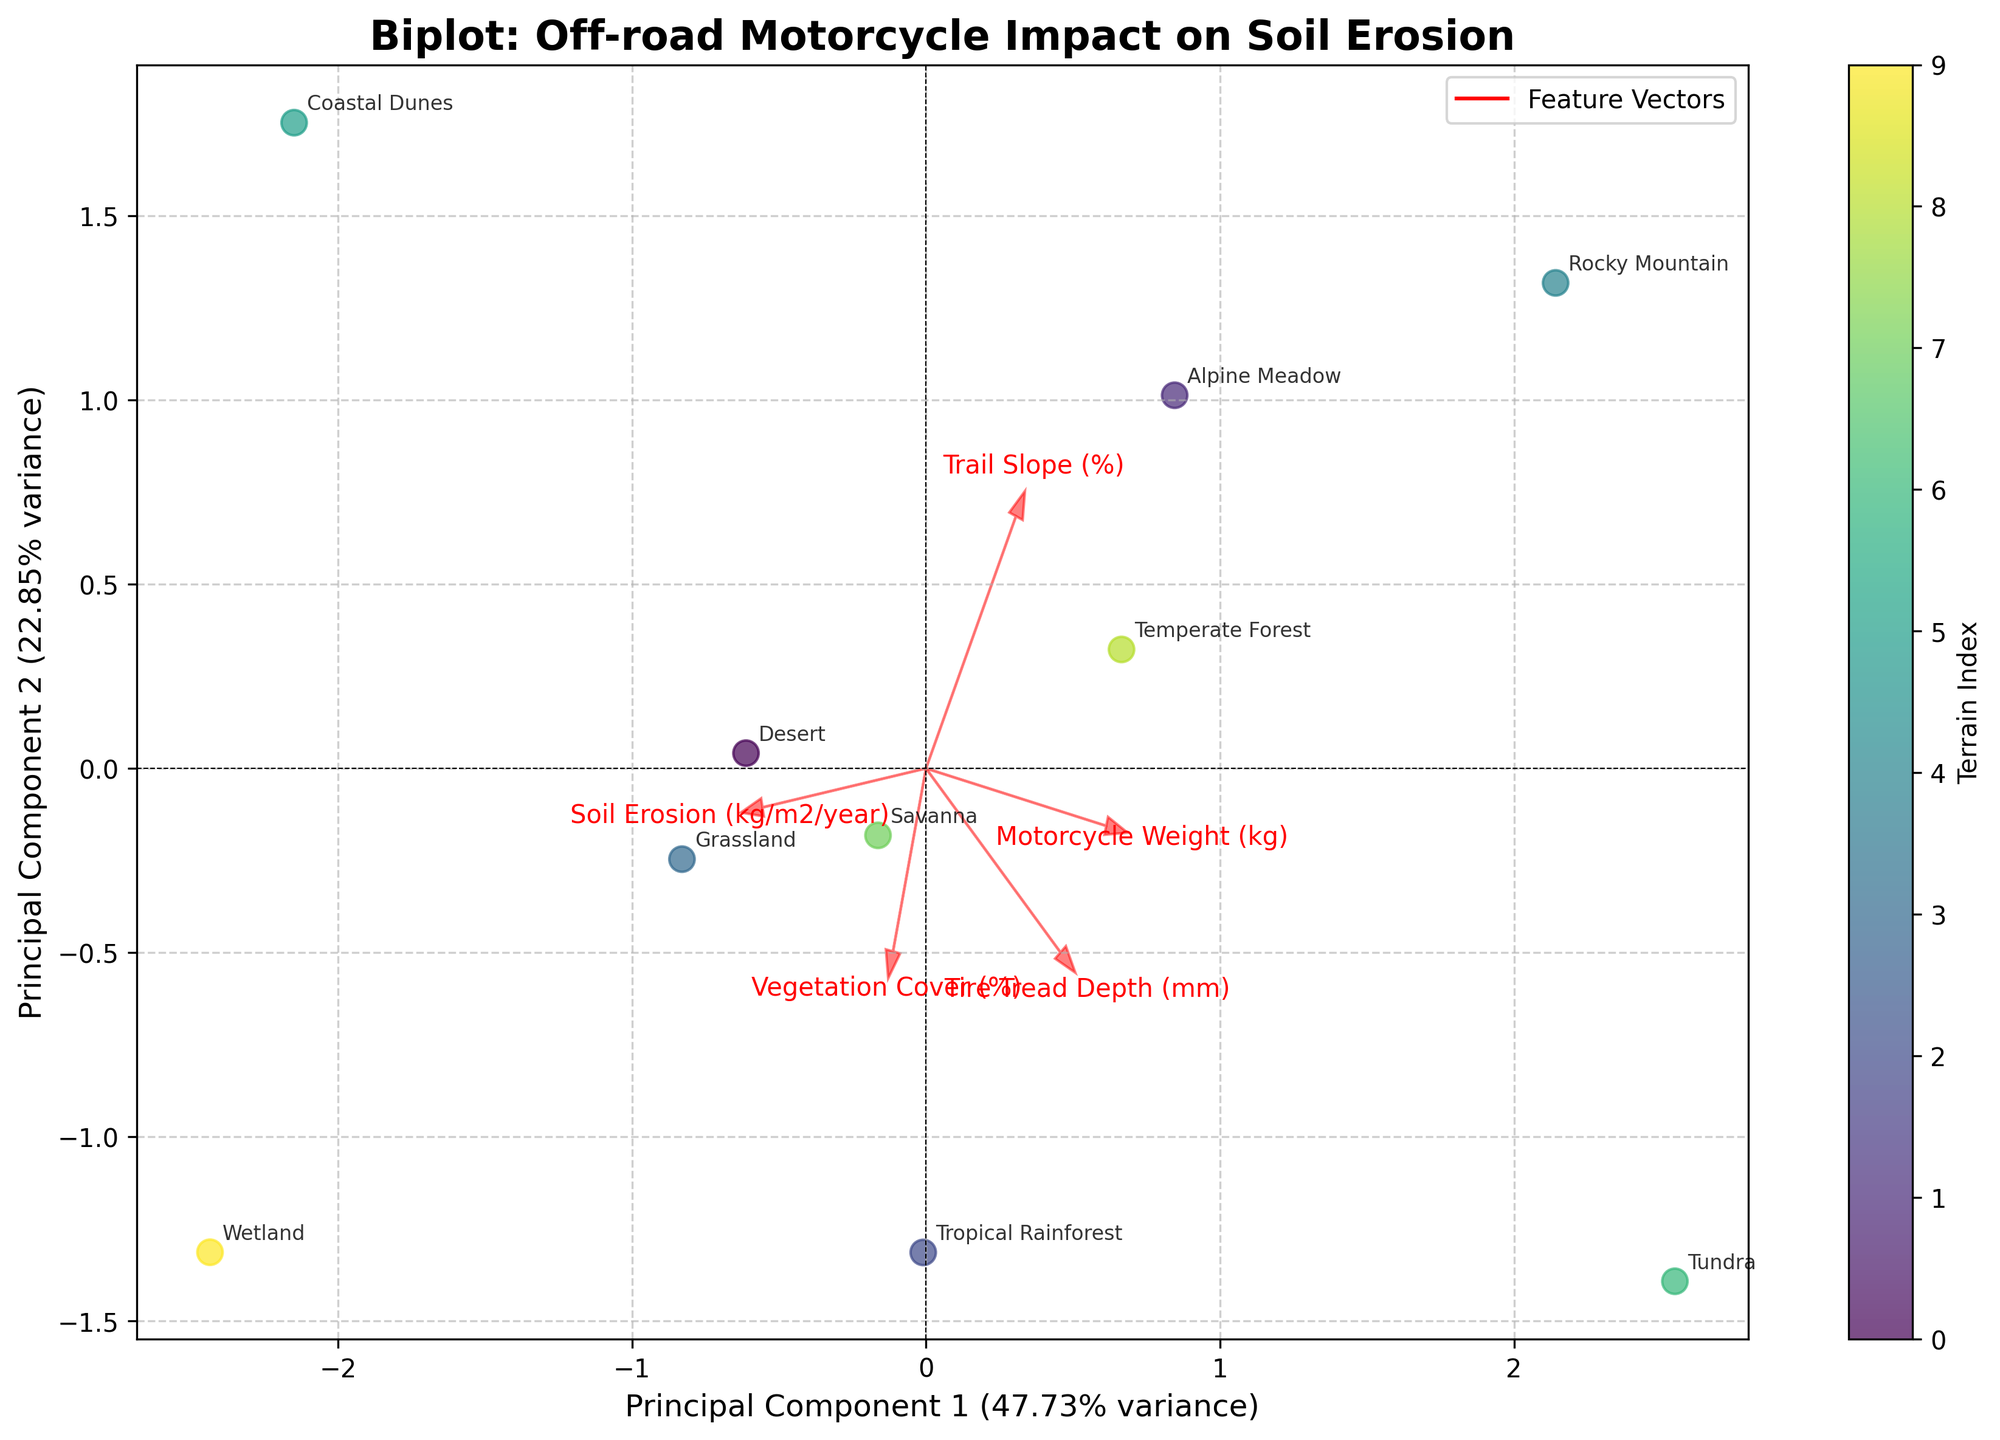Which terrain experiences the highest soil erosion? The terrain with the highest soil erosion is the one plotted farthest along its respective feature vector for 'Soil Erosion (kg/m2/year)'. From the figure, this appears to be the Wetland terrain.
Answer: Wetland What are the two principal components used in this Biplot? The principal components are indicated on the axes, labeled 'Principal Component 1' and 'Principal Component 2'. They represent the two new dimensions obtained from PCA.
Answer: Principal Component 1 and Principal Component 2 Which feature has the smallest impact on the first principal component? By examining the arrows representing feature vectors, the one with the smallest projection on the Principal Component 1 axis has the smallest impact. This appears to be 'Trail Slope (%)'.
Answer: Trail Slope (%) Between 'Alpine Meadow' and 'Desert', which has a higher vegetation cover? We need to look at where 'Alpine Meadow' and 'Desert' are located relative to the 'Vegetation Cover (%)' vector. 'Alpine Meadow' is farther in the direction indicated by the vector, suggesting higher vegetation cover.
Answer: Alpine Meadow Which features are most positively correlated with each other? Features that have arrows pointing in the same direction suggest a positive correlation. 'Vegetation Cover (%)' and 'Tire Tread Depth (mm)' have arrows pointing in similar directions.
Answer: Vegetation Cover (%) and Tire Tread Depth (mm) Which terrain is positioned closest to the origin? The terrain closest to the center where the principal component axes intersect is the one closest to the origin. This appears to be 'Savanna'.
Answer: Savanna Do terrains with higher motorcycle weights tend to have higher or lower soil erosion? By examining the direction of the vectors for 'Motorcycle Weight (kg)' and 'Soil Erosion (kg/m2/year)', we can see if they point similarly or oppositely. The vectors point in different directions, indicating an inverse relationship.
Answer: Lower soil erosion Which terrain has a more considerable impact on soil erosion: 'Rocky Mountain' or 'Tundra'? Compare the positions of 'Rocky Mountain' and 'Tundra' relative to the 'Soil Erosion (kg/m2/year)' vector. 'Rocky Mountain' is farther along the vector, indicating a greater impact.
Answer: Rocky Mountain On this plot, which feature influences the second principal component the most? The feature with the longest projection in the direction of Principal Component 2 influences it the most. This appears to be 'Trail Slope (%)'.
Answer: Trail Slope (%) How do the arrow lengths of 'Soil Erosion (kg/m2/year)' and 'Vegetation Cover (%)' compare? Observing the plot, we compare the lengths of the arrows representing these features. 'Vegetation Cover (%)' appears to have a longer arrow than 'Soil Erosion (kg/m2/year)', indicating it potentially explains a larger variance in the data.
Answer: 'Vegetation Cover (%)' is longer 